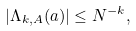Convert formula to latex. <formula><loc_0><loc_0><loc_500><loc_500>| \Lambda _ { k , A } ( a ) | \leq N ^ { - k } ,</formula> 